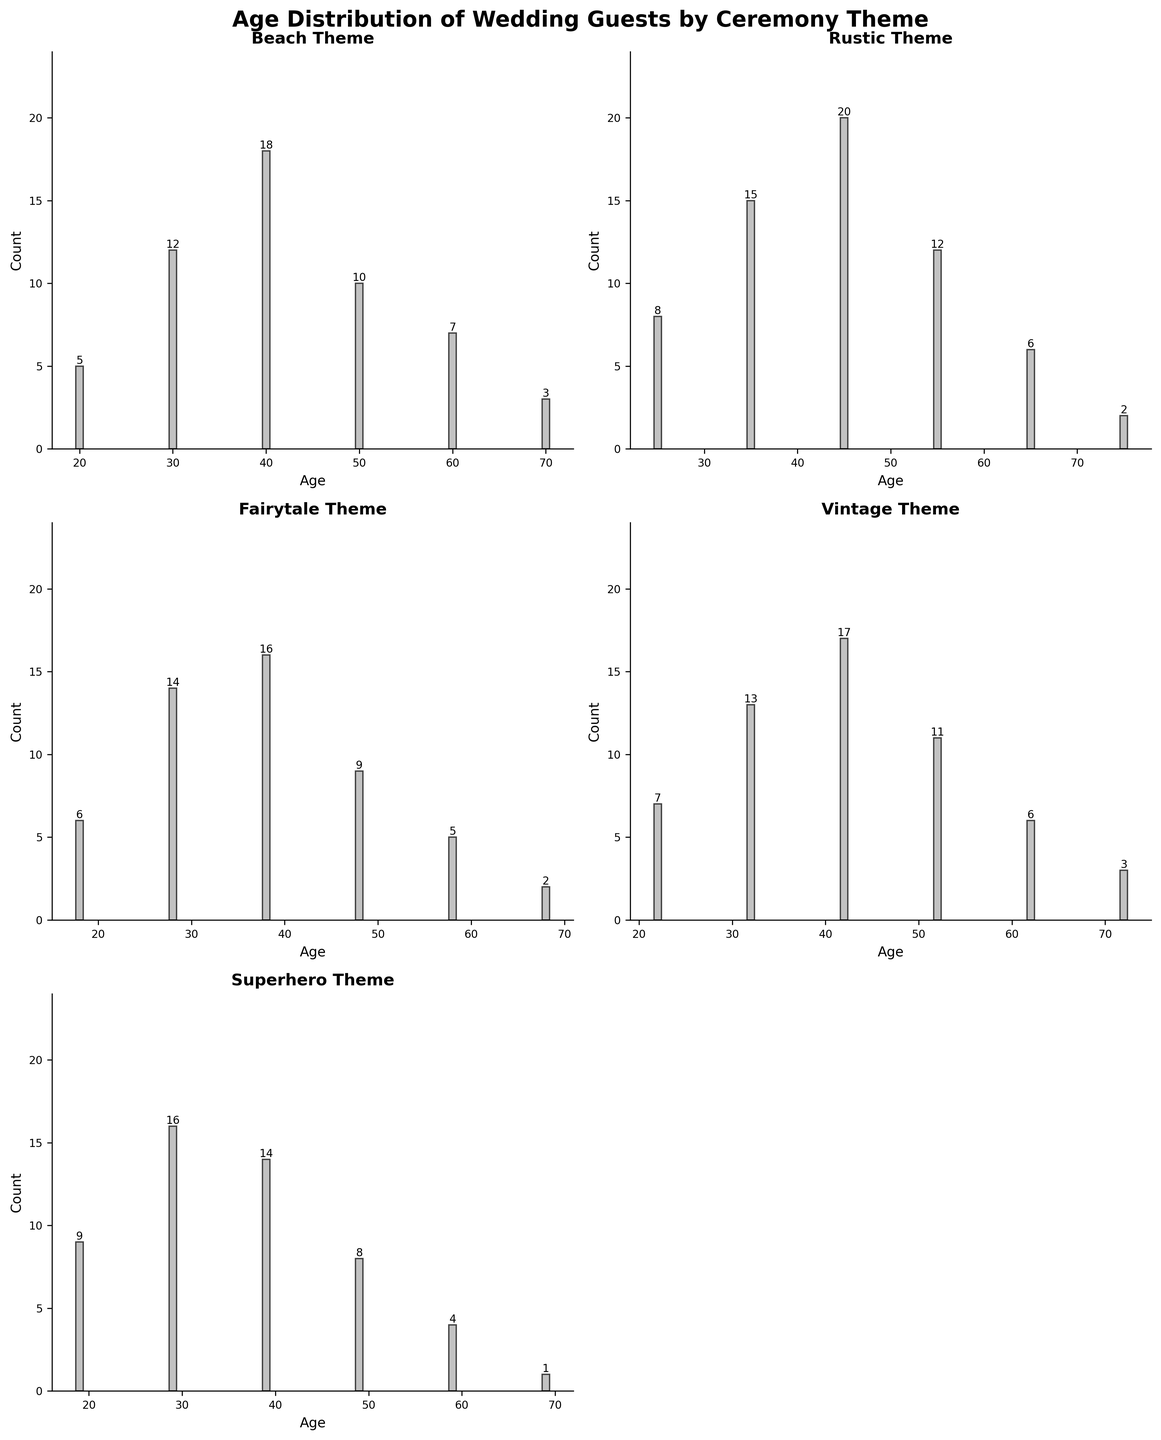What's the title of the figure? The title of the figure is located at the top and provides an overview of what the figure represents.
Answer: Age Distribution of Wedding Guests by Ceremony Theme How many themes are displayed in the figure? Each subplot represents a different ceremony theme. Counting the subplots gives the total number of themes.
Answer: 5 What's the age range with the highest guest count in the Beach theme? Find the bar with the highest value within the Beach theme subplot, then identify its corresponding age range.
Answer: 40 In the Fairytale theme, which age range has the lowest count of guests? Look at the bar heights in the Fairytale subplot to determine which one is the shortest, then identify its age range.
Answer: 68 How many guests are in the 35 years age range for the Rustic theme? Locate the bar corresponding to the age of 35 in the Rustic subplot and read the guest count at the top of the bar.
Answer: 15 Which theme has the highest count of guests in the 50 years age range? Compare the bar heights for the 50 years age range across all subplots to see which is the tallest.
Answer: Beach What is the total number of guests in the 40 years age range across all themes? Add the guest counts for the 40 years age range from each subplot: Beach (18), Rustic (20), Fairytale (16), Vintage (17), and Superhero (14). So, 18 + 20 + 16 + 17 + 14 = 85
Answer: 85 Which theme has the smallest peak guest count? Identify the theme by finding the subplot with the shortest tallest bar across all subplots.
Answer: Fairytale Between the Beach and Rustic themes, which one has more guests in the 60 years age range and by how much? Compare the guest count for the 60 years age range in the Beach (7) and Rustic (6) subplots. The difference is 7 - 6 = 1.
Answer: Beach by 1 What is the average guest count for the 28 years old range in the Fairytale theme? There's only one bar for the age of 28 in the Fairytale theme. Directly read the guest count from this bar.
Answer: 14 